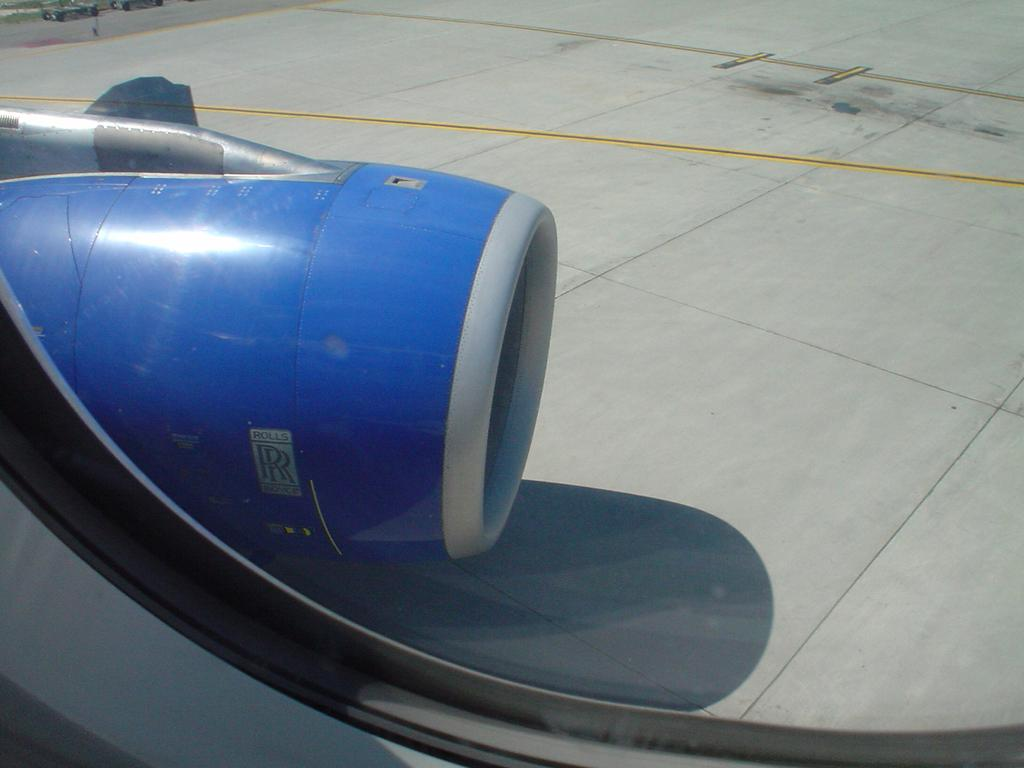What can be seen in the image related to a source of light or air? There is a window in the image. What is visible through the window? An object on the ground is visible through the window. Can you see any veins in the image? There are no veins visible in the image, as it features a window and an object on the ground. How does the adjustment of the window affect the rice in the image? There is no rice present in the image, so the adjustment of the window does not affect any rice. 